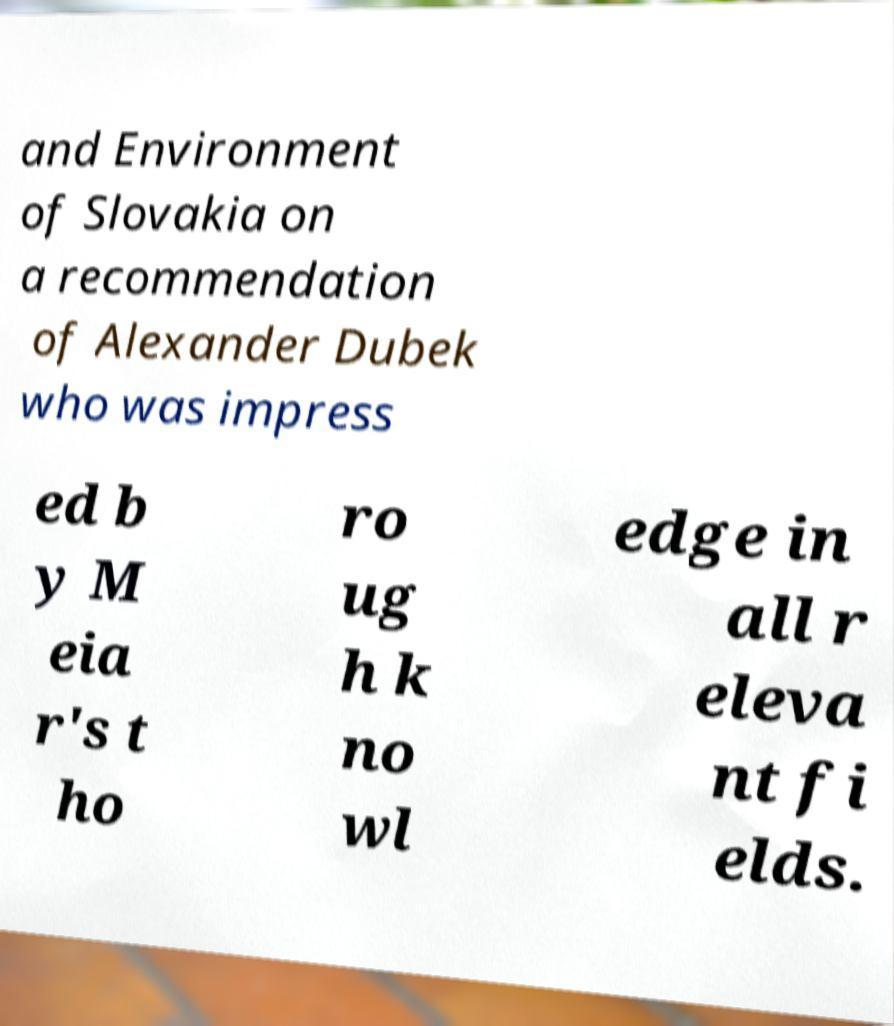Please read and relay the text visible in this image. What does it say? and Environment of Slovakia on a recommendation of Alexander Dubek who was impress ed b y M eia r's t ho ro ug h k no wl edge in all r eleva nt fi elds. 